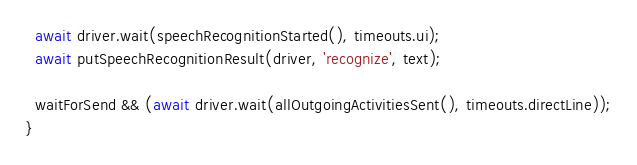<code> <loc_0><loc_0><loc_500><loc_500><_JavaScript_>
  await driver.wait(speechRecognitionStarted(), timeouts.ui);
  await putSpeechRecognitionResult(driver, 'recognize', text);

  waitForSend && (await driver.wait(allOutgoingActivitiesSent(), timeouts.directLine));
}
</code> 